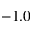Convert formula to latex. <formula><loc_0><loc_0><loc_500><loc_500>- 1 . 0</formula> 